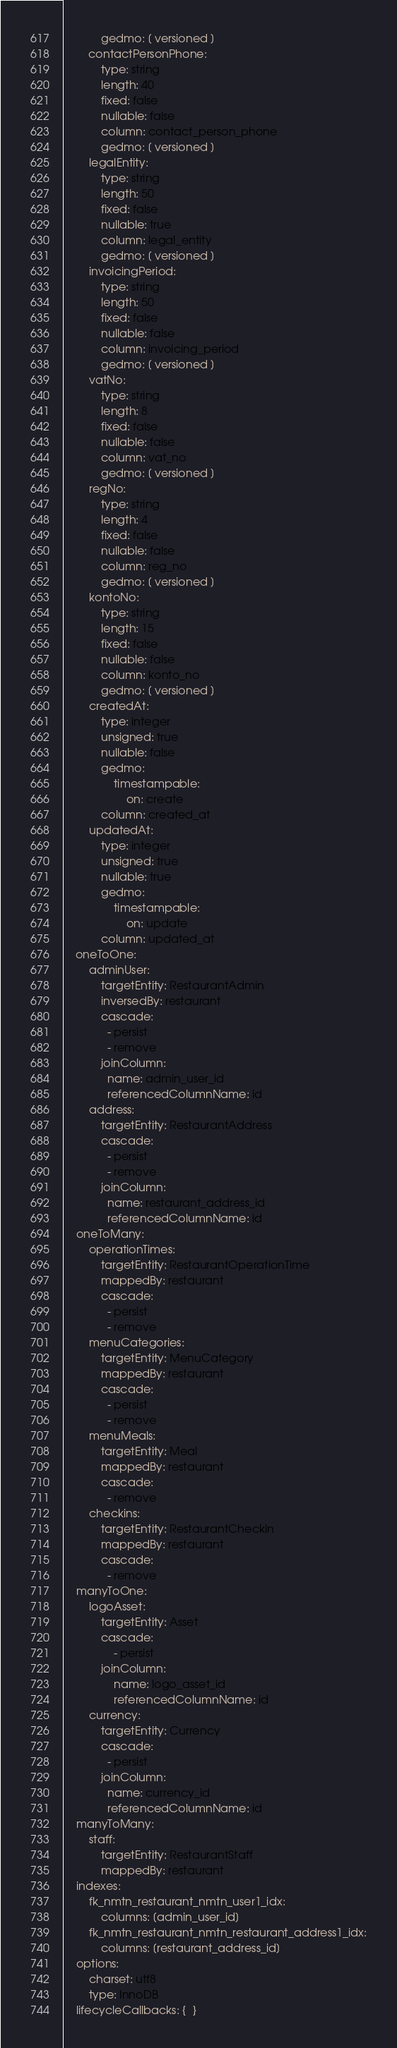<code> <loc_0><loc_0><loc_500><loc_500><_YAML_>            gedmo: [ versioned ]
        contactPersonPhone:
            type: string
            length: 40
            fixed: false
            nullable: false
            column: contact_person_phone
            gedmo: [ versioned ]
        legalEntity:
            type: string
            length: 50
            fixed: false
            nullable: true
            column: legal_entity
            gedmo: [ versioned ]
        invoicingPeriod:
            type: string
            length: 50
            fixed: false
            nullable: false
            column: invoicing_period
            gedmo: [ versioned ]
        vatNo:
            type: string
            length: 8
            fixed: false
            nullable: false
            column: vat_no
            gedmo: [ versioned ]
        regNo:
            type: string
            length: 4
            fixed: false
            nullable: false
            column: reg_no
            gedmo: [ versioned ]
        kontoNo:
            type: string
            length: 15
            fixed: false
            nullable: false
            column: konto_no
            gedmo: [ versioned ]
        createdAt:
            type: integer
            unsigned: true
            nullable: false
            gedmo:
                timestampable:
                    on: create
            column: created_at
        updatedAt:
            type: integer
            unsigned: true
            nullable: true
            gedmo:
                timestampable:
                    on: update
            column: updated_at
    oneToOne:
        adminUser:
            targetEntity: RestaurantAdmin
            inversedBy: restaurant
            cascade:
              - persist
              - remove
            joinColumn:
              name: admin_user_id
              referencedColumnName: id
        address:
            targetEntity: RestaurantAddress
            cascade:
              - persist
              - remove
            joinColumn:
              name: restaurant_address_id
              referencedColumnName: id
    oneToMany:
        operationTimes:
            targetEntity: RestaurantOperationTime
            mappedBy: restaurant
            cascade:
              - persist
              - remove
        menuCategories:
            targetEntity: MenuCategory
            mappedBy: restaurant
            cascade:
              - persist
              - remove
        menuMeals:
            targetEntity: Meal
            mappedBy: restaurant
            cascade:
              - remove
        checkins:
            targetEntity: RestaurantCheckin
            mappedBy: restaurant
            cascade:
              - remove
    manyToOne:
        logoAsset:
            targetEntity: Asset
            cascade:
                - persist
            joinColumn:
                name: logo_asset_id
                referencedColumnName: id
        currency:
            targetEntity: Currency
            cascade:
              - persist
            joinColumn:
              name: currency_id
              referencedColumnName: id
    manyToMany:
        staff:
            targetEntity: RestaurantStaff
            mappedBy: restaurant
    indexes:
        fk_nmtn_restaurant_nmtn_user1_idx:
            columns: [admin_user_id]
        fk_nmtn_restaurant_nmtn_restaurant_address1_idx:
            columns: [restaurant_address_id]
    options:
        charset: utf8
        type: InnoDB
    lifecycleCallbacks: {  }
</code> 